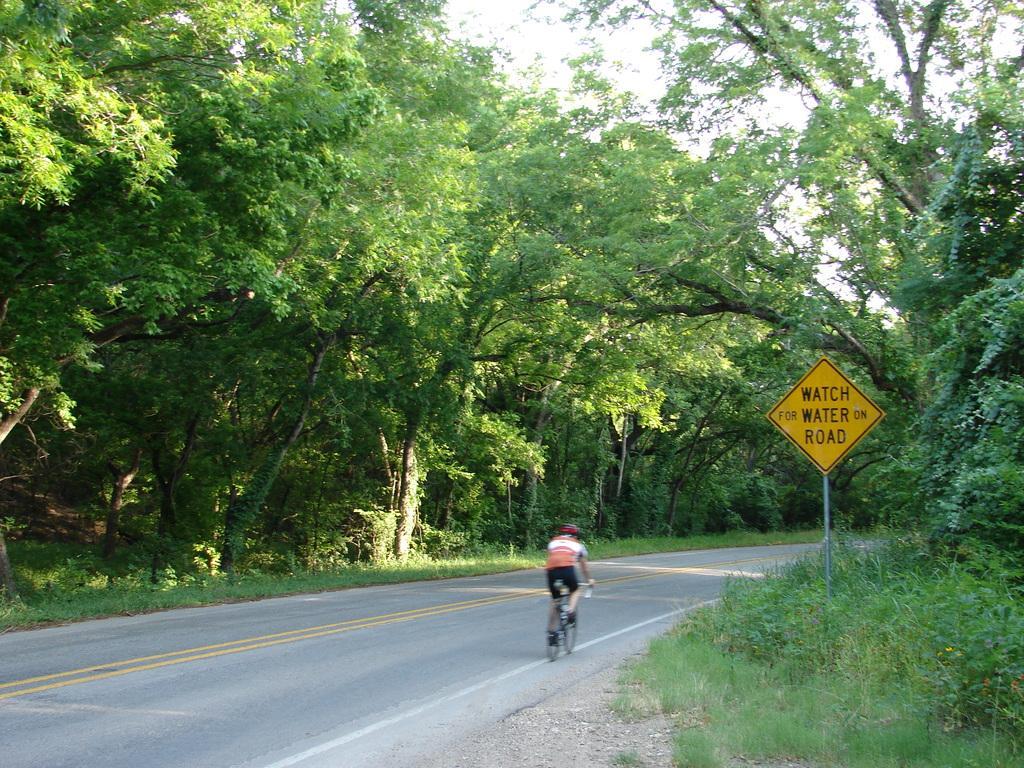How would you summarize this image in a sentence or two? In the image I can see a person who is riding the bicycle on the road and also I can see some trees, plants and a board on which there is some text. 